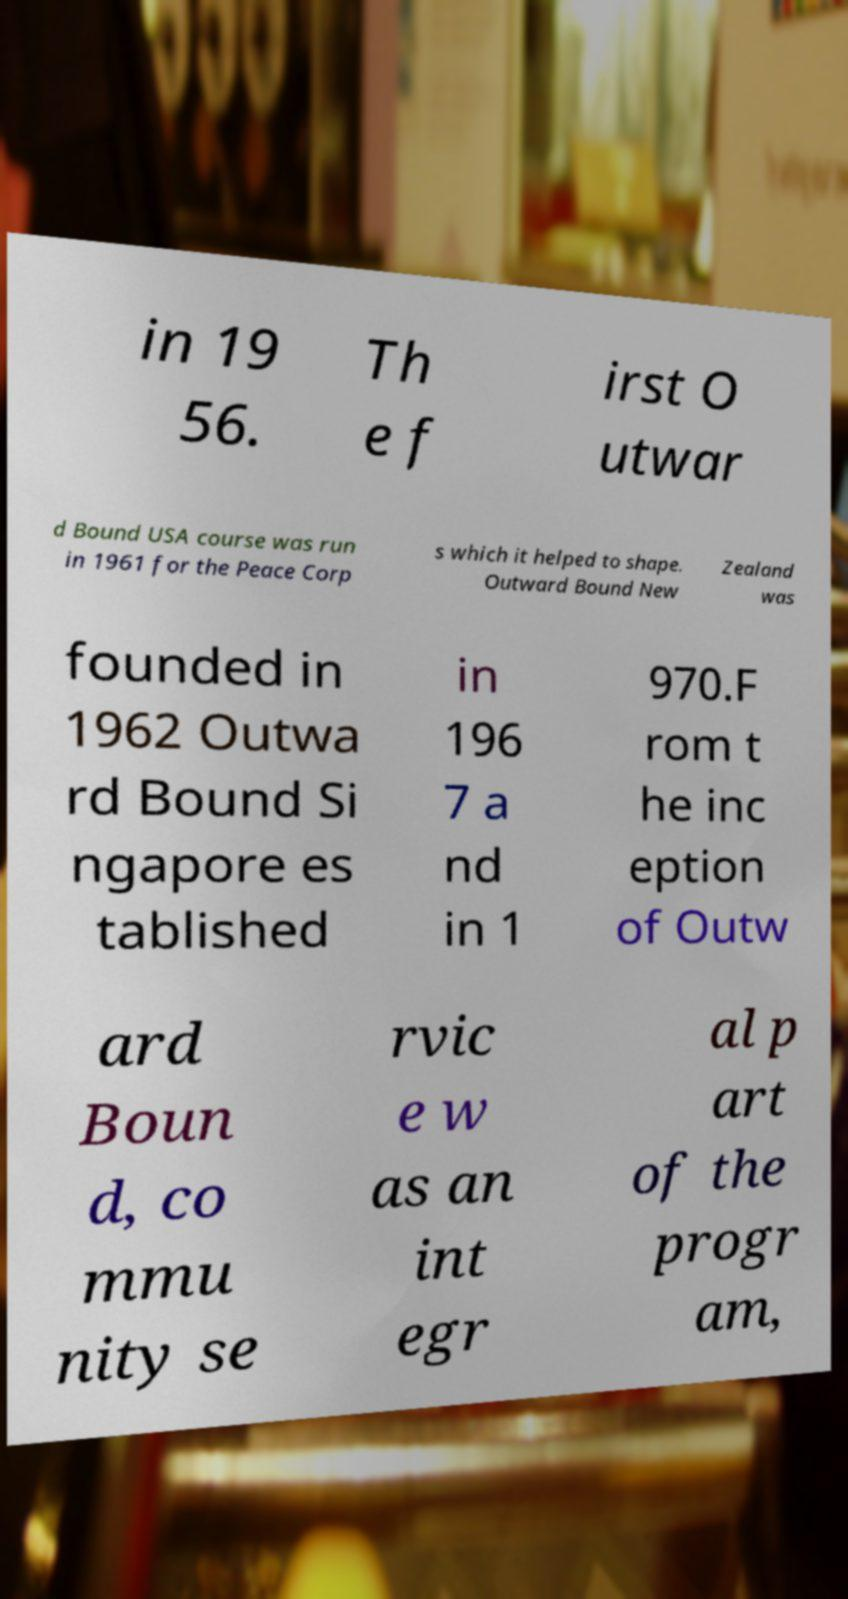Can you accurately transcribe the text from the provided image for me? in 19 56. Th e f irst O utwar d Bound USA course was run in 1961 for the Peace Corp s which it helped to shape. Outward Bound New Zealand was founded in 1962 Outwa rd Bound Si ngapore es tablished in 196 7 a nd in 1 970.F rom t he inc eption of Outw ard Boun d, co mmu nity se rvic e w as an int egr al p art of the progr am, 